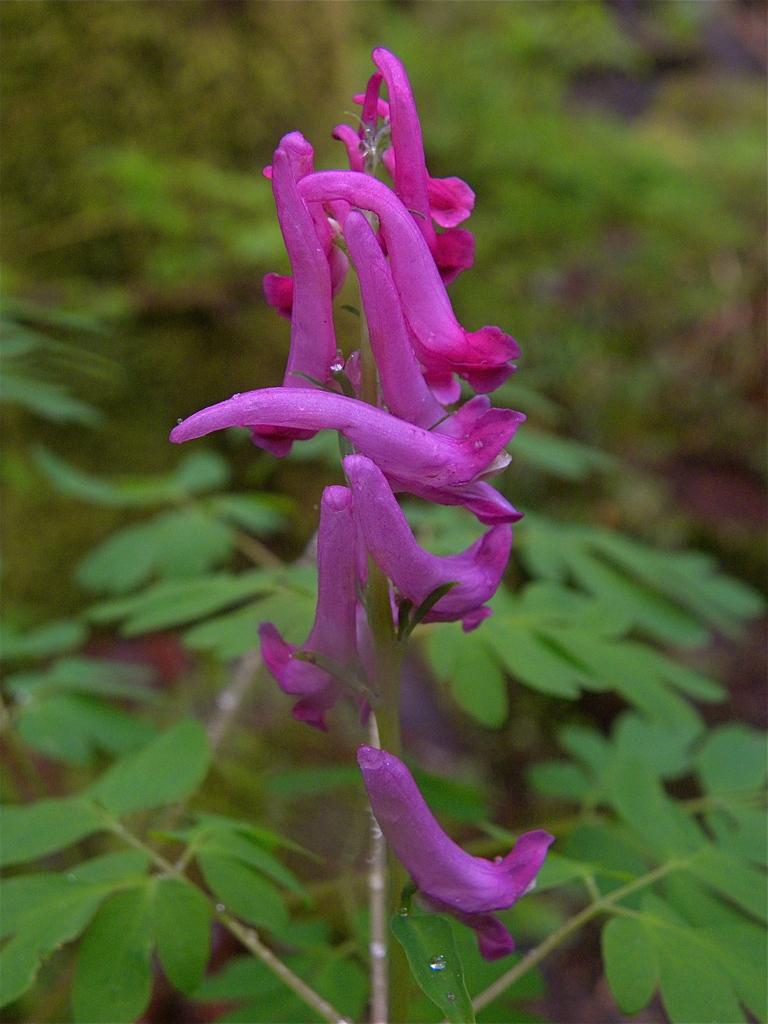What type of vegetation can be seen in the image? There are flowers, plants, and trees in the image. Can you describe the different types of vegetation present? The image contains flowers, which are smaller and more colorful, plants, which are typically smaller than trees and have leaves, and trees, which are larger and have a trunk. What type of whistle can be seen in the image? There is no whistle present in the image; it only contains vegetation. 